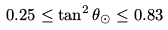Convert formula to latex. <formula><loc_0><loc_0><loc_500><loc_500>0 . 2 5 \leq \tan ^ { 2 } \theta _ { \odot } \leq 0 . 8 3</formula> 